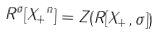<formula> <loc_0><loc_0><loc_500><loc_500>R ^ { \sigma } [ { X _ { + } } ^ { n } ] = Z ( R [ X _ { + } , \sigma ] )</formula> 